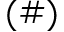Convert formula to latex. <formula><loc_0><loc_0><loc_500><loc_500>( \# )</formula> 